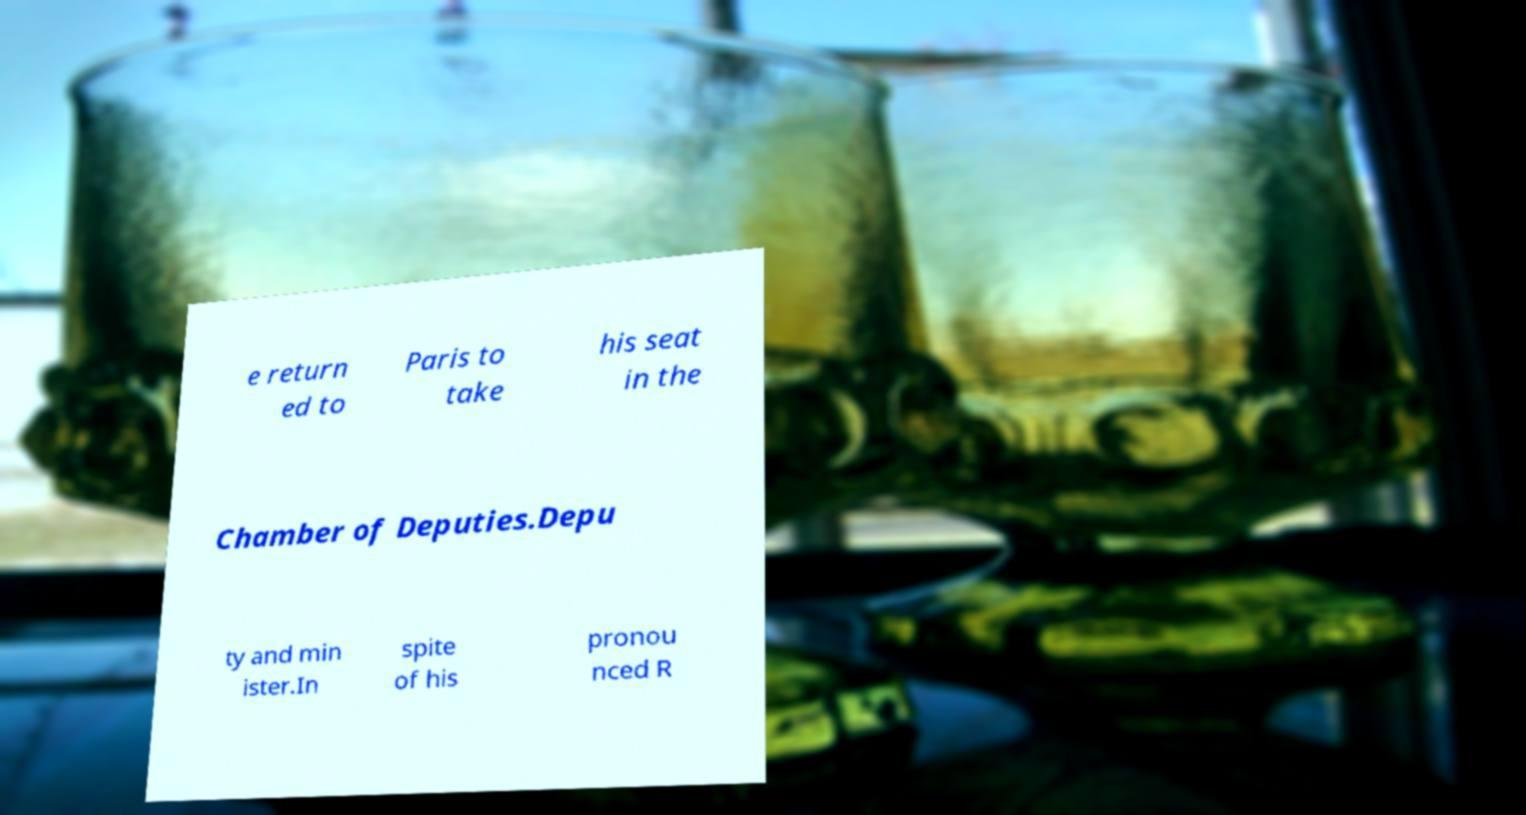What messages or text are displayed in this image? I need them in a readable, typed format. e return ed to Paris to take his seat in the Chamber of Deputies.Depu ty and min ister.In spite of his pronou nced R 